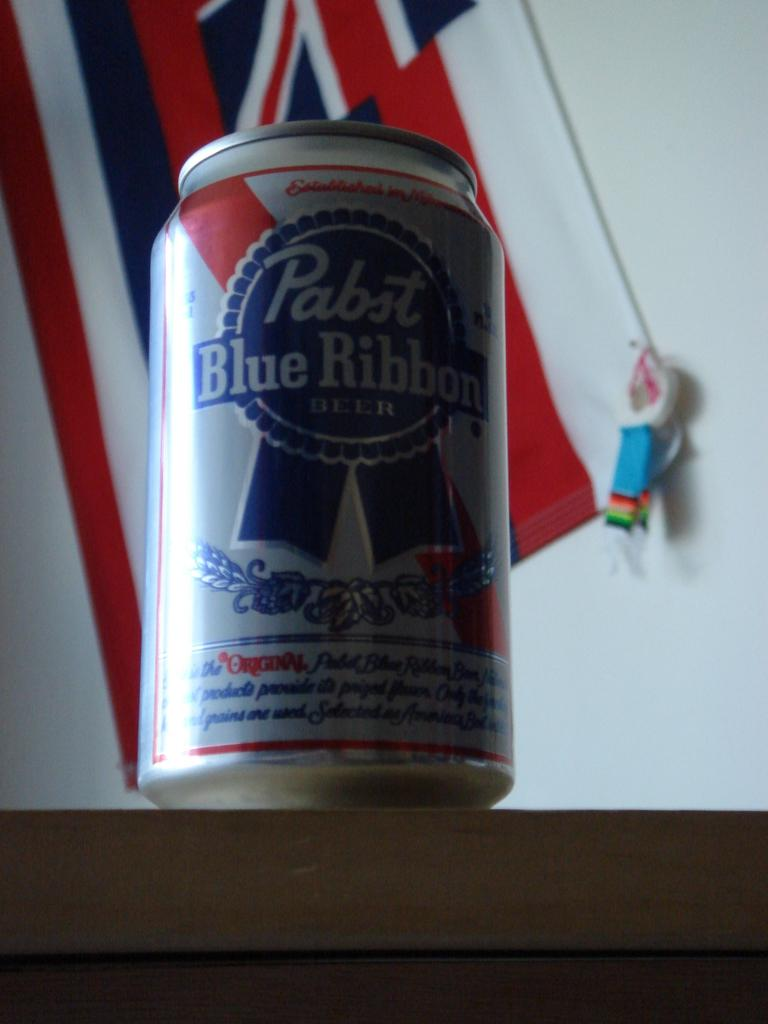<image>
Write a terse but informative summary of the picture. Red and silver beer can which says "Blue Ribbon" on it. 